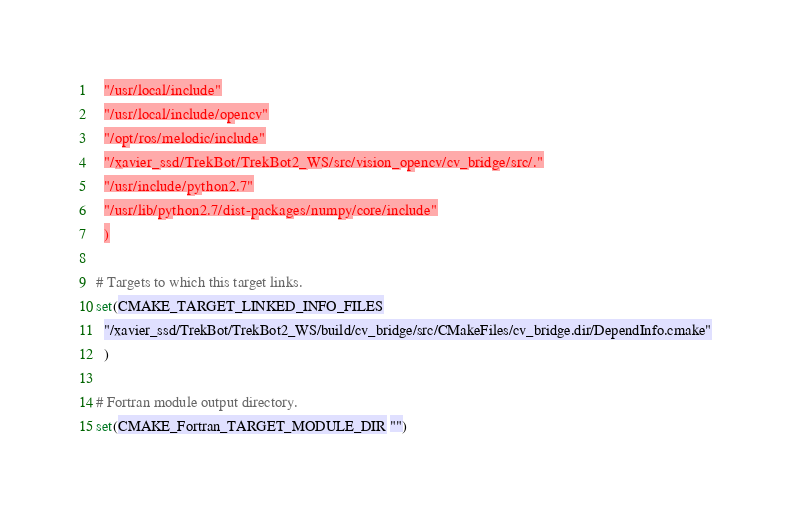<code> <loc_0><loc_0><loc_500><loc_500><_CMake_>  "/usr/local/include"
  "/usr/local/include/opencv"
  "/opt/ros/melodic/include"
  "/xavier_ssd/TrekBot/TrekBot2_WS/src/vision_opencv/cv_bridge/src/."
  "/usr/include/python2.7"
  "/usr/lib/python2.7/dist-packages/numpy/core/include"
  )

# Targets to which this target links.
set(CMAKE_TARGET_LINKED_INFO_FILES
  "/xavier_ssd/TrekBot/TrekBot2_WS/build/cv_bridge/src/CMakeFiles/cv_bridge.dir/DependInfo.cmake"
  )

# Fortran module output directory.
set(CMAKE_Fortran_TARGET_MODULE_DIR "")
</code> 